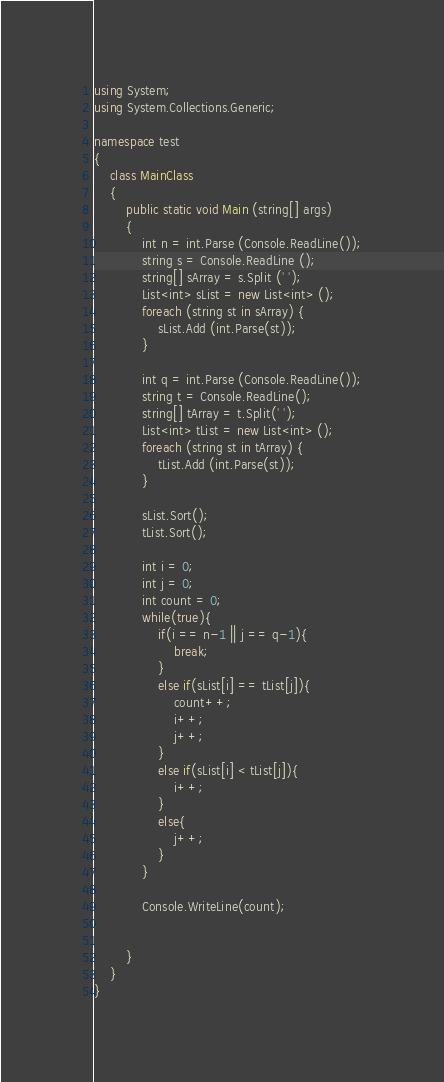<code> <loc_0><loc_0><loc_500><loc_500><_C#_>using System;
using System.Collections.Generic;

namespace test
{
	class MainClass
	{
		public static void Main (string[] args)
		{
			int n = int.Parse (Console.ReadLine());
			string s = Console.ReadLine ();
			string[] sArray = s.Split (' ');
			List<int> sList = new List<int> ();
			foreach (string st in sArray) {
				sList.Add (int.Parse(st));
			}

			int q = int.Parse (Console.ReadLine());
			string t = Console.ReadLine();
			string[] tArray = t.Split(' ');
			List<int> tList = new List<int> ();
			foreach (string st in tArray) {
				tList.Add (int.Parse(st));
			}

			sList.Sort();
			tList.Sort();

			int i = 0;
			int j = 0;
			int count = 0;
			while(true){
				if(i == n-1 || j == q-1){
					break;
				}
				else if(sList[i] == tList[j]){
					count++;
					i++;
					j++;
				}
				else if(sList[i] < tList[j]){
					i++;
				}
				else{
					j++;
				}
			}

			Console.WriteLine(count);


		}
	}
}</code> 